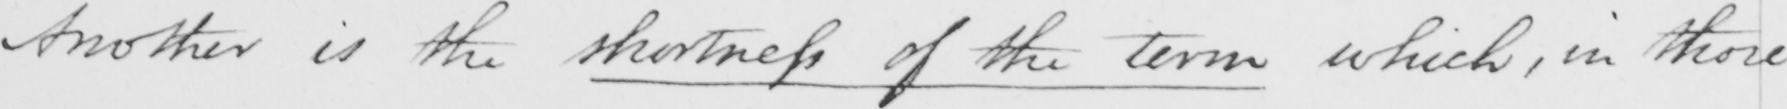What text is written in this handwritten line? Another is the shortness of the term which , in those 